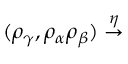<formula> <loc_0><loc_0><loc_500><loc_500>( \rho _ { \gamma } , \rho _ { \alpha } \rho _ { \beta } ) \stackrel { \eta } { \rightarrow }</formula> 